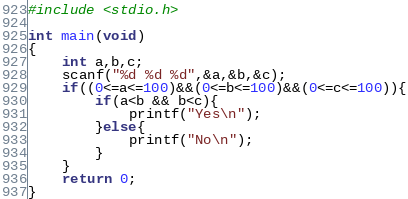<code> <loc_0><loc_0><loc_500><loc_500><_C_>#include <stdio.h>

int main(void)
{
	int a,b,c;
	scanf("%d %d %d",&a,&b,&c);
	if((0<=a<=100)&&(0<=b<=100)&&(0<=c<=100)){
		if(a<b && b<c){
			printf("Yes\n");
		}else{
			printf("No\n");
		}
	}
	return 0;
}</code> 